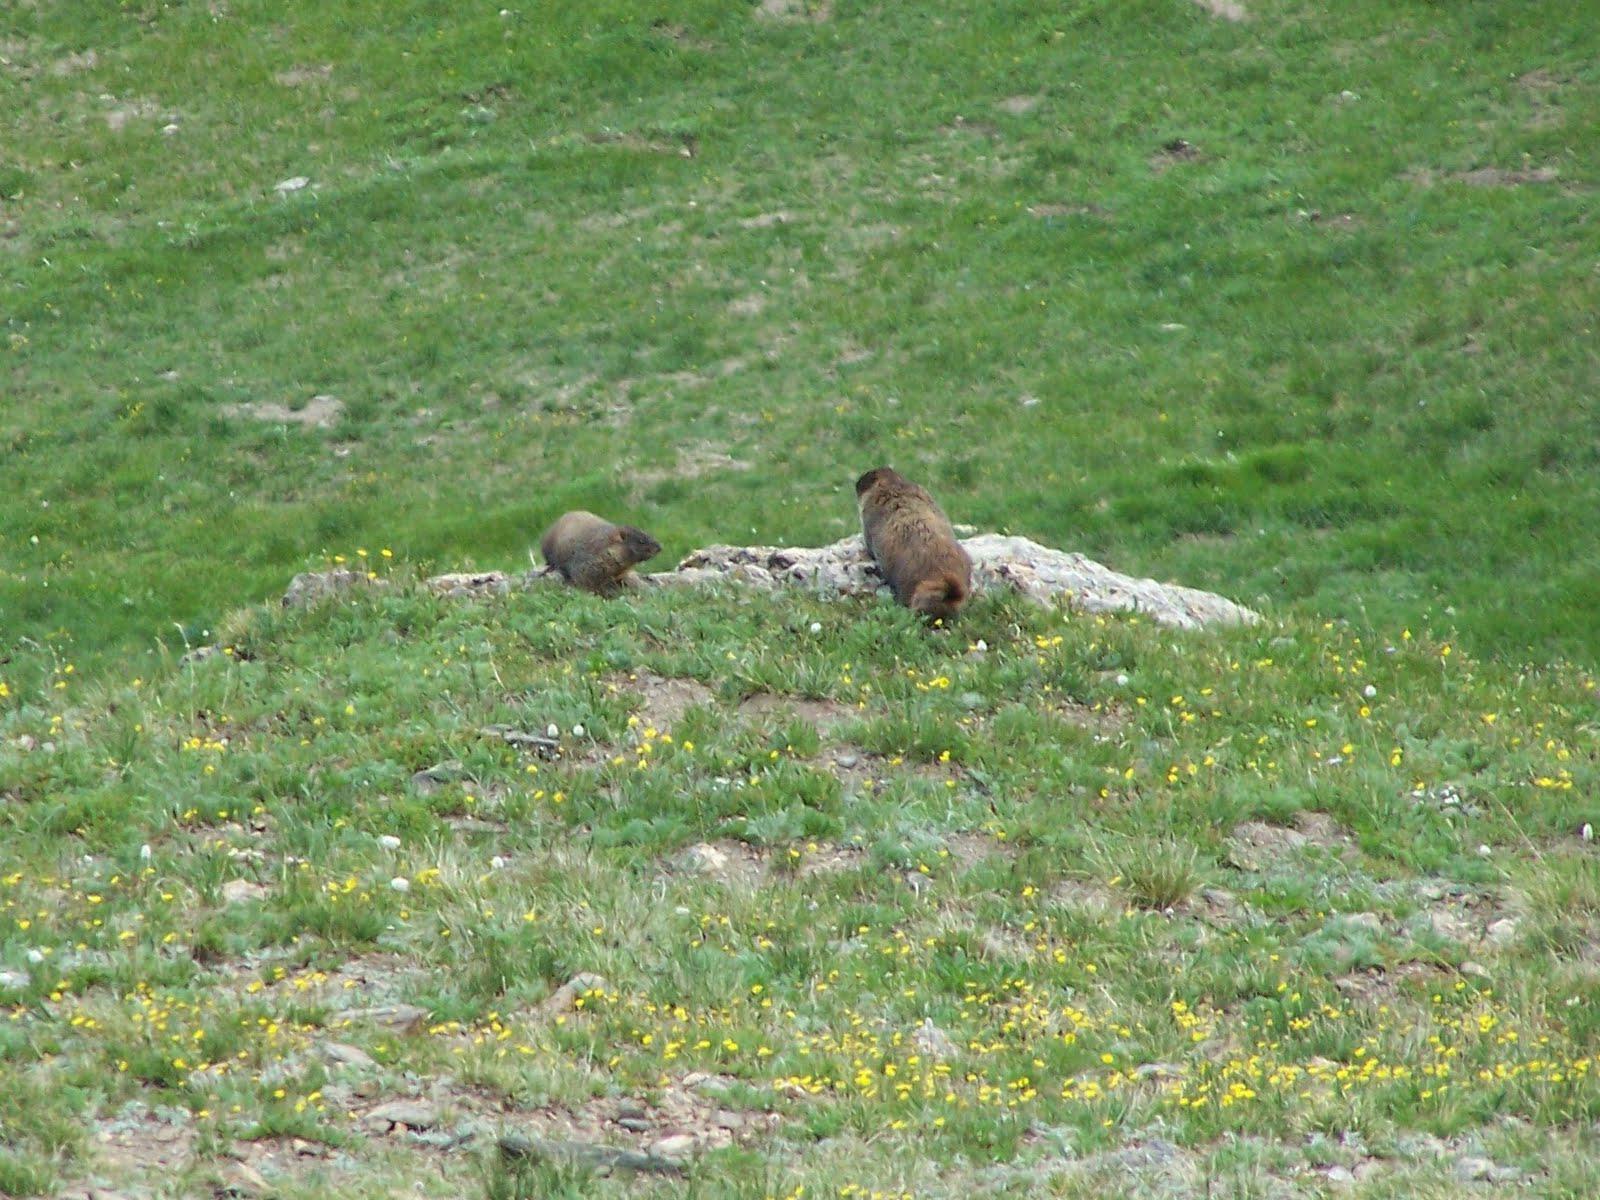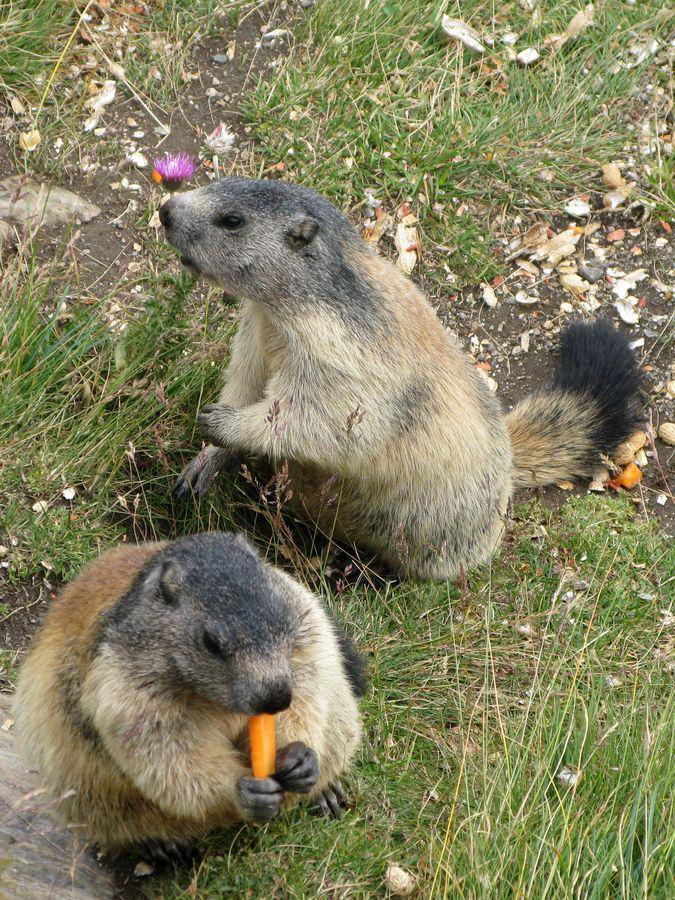The first image is the image on the left, the second image is the image on the right. Assess this claim about the two images: "There is only one animal is eating.". Correct or not? Answer yes or no. Yes. The first image is the image on the left, the second image is the image on the right. Considering the images on both sides, is "There are at least two animals in the image on the right." valid? Answer yes or no. Yes. 